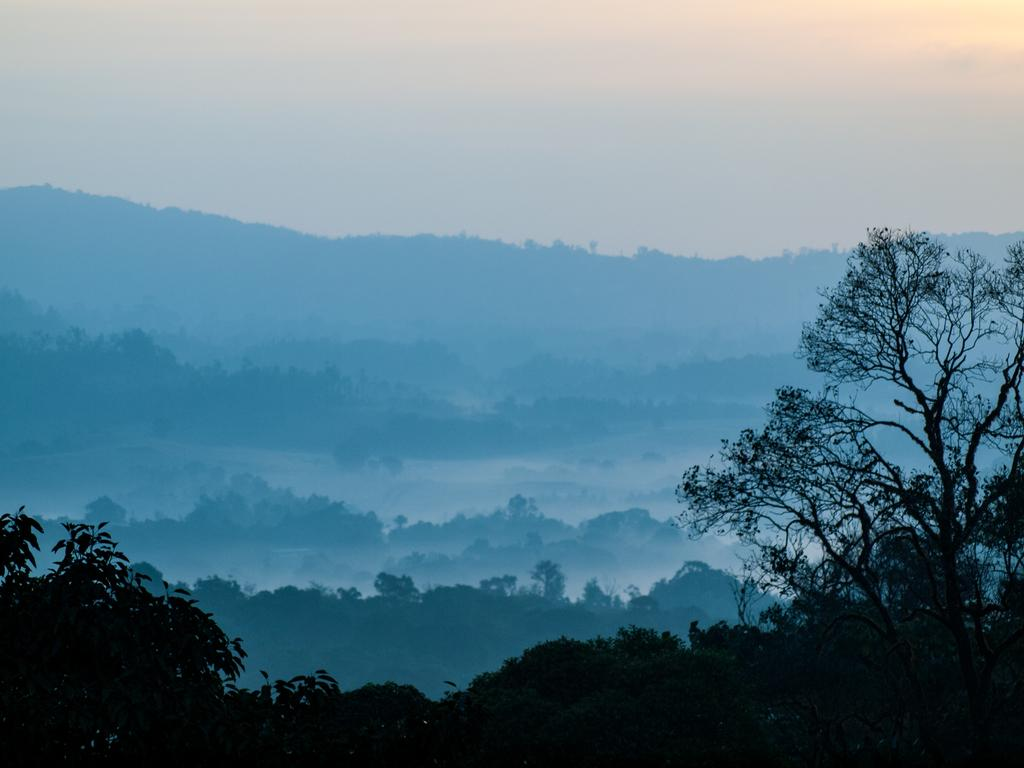What type of surface can be seen at the bottom of the image? The ground is visible in the image. What type of vegetation is present in the image? There are trees and plants in the image. What is visible above the trees and plants in the image? The sky is visible in the image. What type of advice can be seen written on the quilt in the image? There is no quilt or advice present in the image. What color are the tooth's enamel in the image? There is no tooth present in the image. 